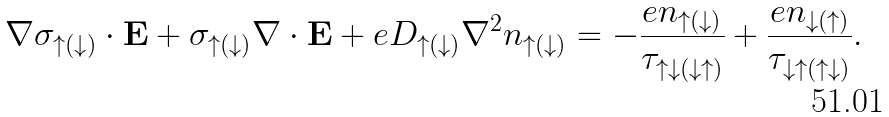<formula> <loc_0><loc_0><loc_500><loc_500>\nabla \sigma _ { \uparrow ( \downarrow ) } \cdot { \mathbf E } + \sigma _ { \uparrow ( \downarrow ) } \nabla \cdot { \mathbf E } + e D _ { \uparrow ( \downarrow ) } \nabla ^ { 2 } n _ { \uparrow ( \downarrow ) } = - \frac { e n _ { \uparrow ( \downarrow ) } } { \tau _ { \uparrow \downarrow ( \downarrow \uparrow ) } } + \frac { e n _ { \downarrow ( \uparrow ) } } { \tau _ { \downarrow \uparrow ( \uparrow \downarrow ) } } .</formula> 